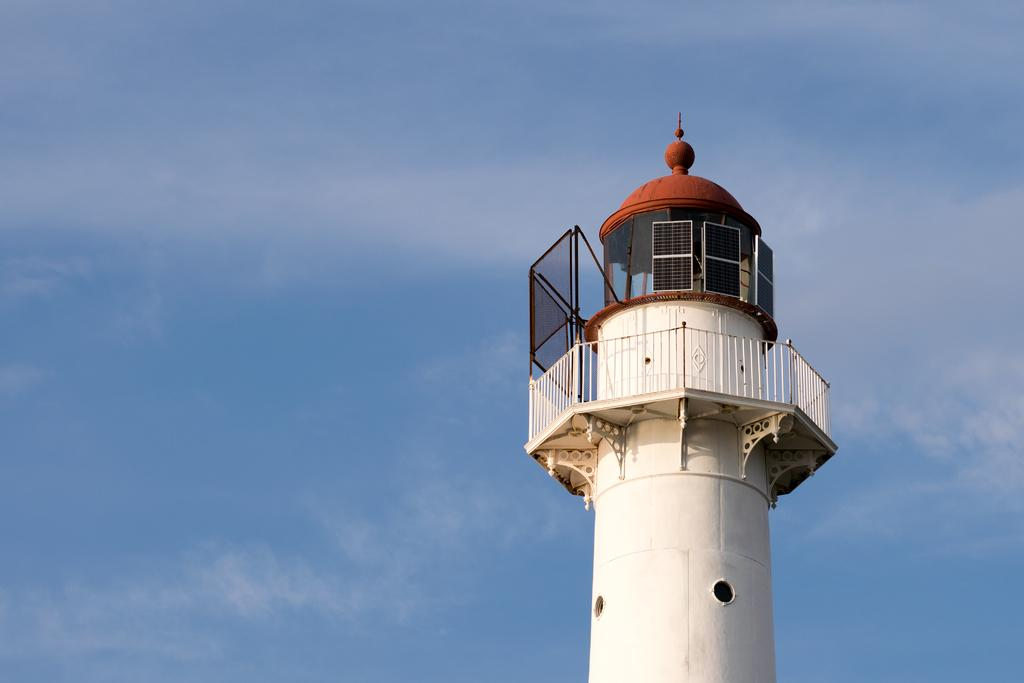What is the main structure in the image? There is a tower in the image. What colors can be seen on the tower? The tower is cream, black, and brown in color. What feature surrounds the tower? There is a white-colored railing around the tower. What can be seen in the background of the image? The sky is visible in the background of the image. What type of blood is visible on the tower in the image? There is no blood visible on the tower in the image. What kind of thread is used to create the tower in the image? The tower in the image is a solid structure and does not involve thread. 